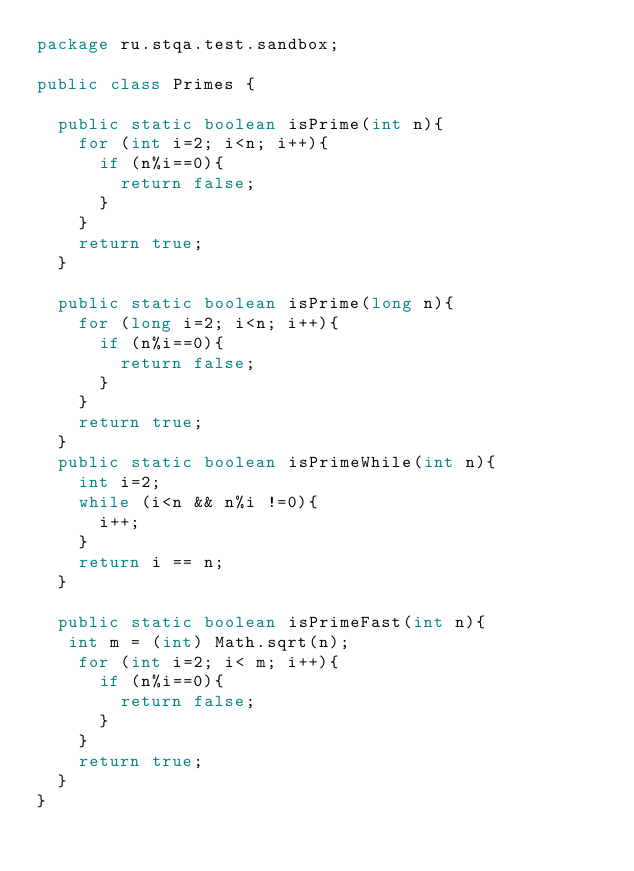Convert code to text. <code><loc_0><loc_0><loc_500><loc_500><_Java_>package ru.stqa.test.sandbox;

public class Primes {

  public static boolean isPrime(int n){
    for (int i=2; i<n; i++){
      if (n%i==0){
        return false;
      }
    }
    return true;
  }

  public static boolean isPrime(long n){
    for (long i=2; i<n; i++){
      if (n%i==0){
        return false;
      }
    }
    return true;
  }
  public static boolean isPrimeWhile(int n){
    int i=2;
    while (i<n && n%i !=0){
      i++;
    }
    return i == n;
  }

  public static boolean isPrimeFast(int n){
   int m = (int) Math.sqrt(n);
    for (int i=2; i< m; i++){
      if (n%i==0){
        return false;
      }
    }
    return true;
  }
}
</code> 